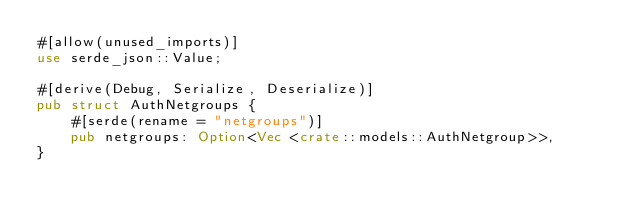Convert code to text. <code><loc_0><loc_0><loc_500><loc_500><_Rust_>#[allow(unused_imports)]
use serde_json::Value;

#[derive(Debug, Serialize, Deserialize)]
pub struct AuthNetgroups {
    #[serde(rename = "netgroups")]
    pub netgroups: Option<Vec <crate::models::AuthNetgroup>>,
}
</code> 